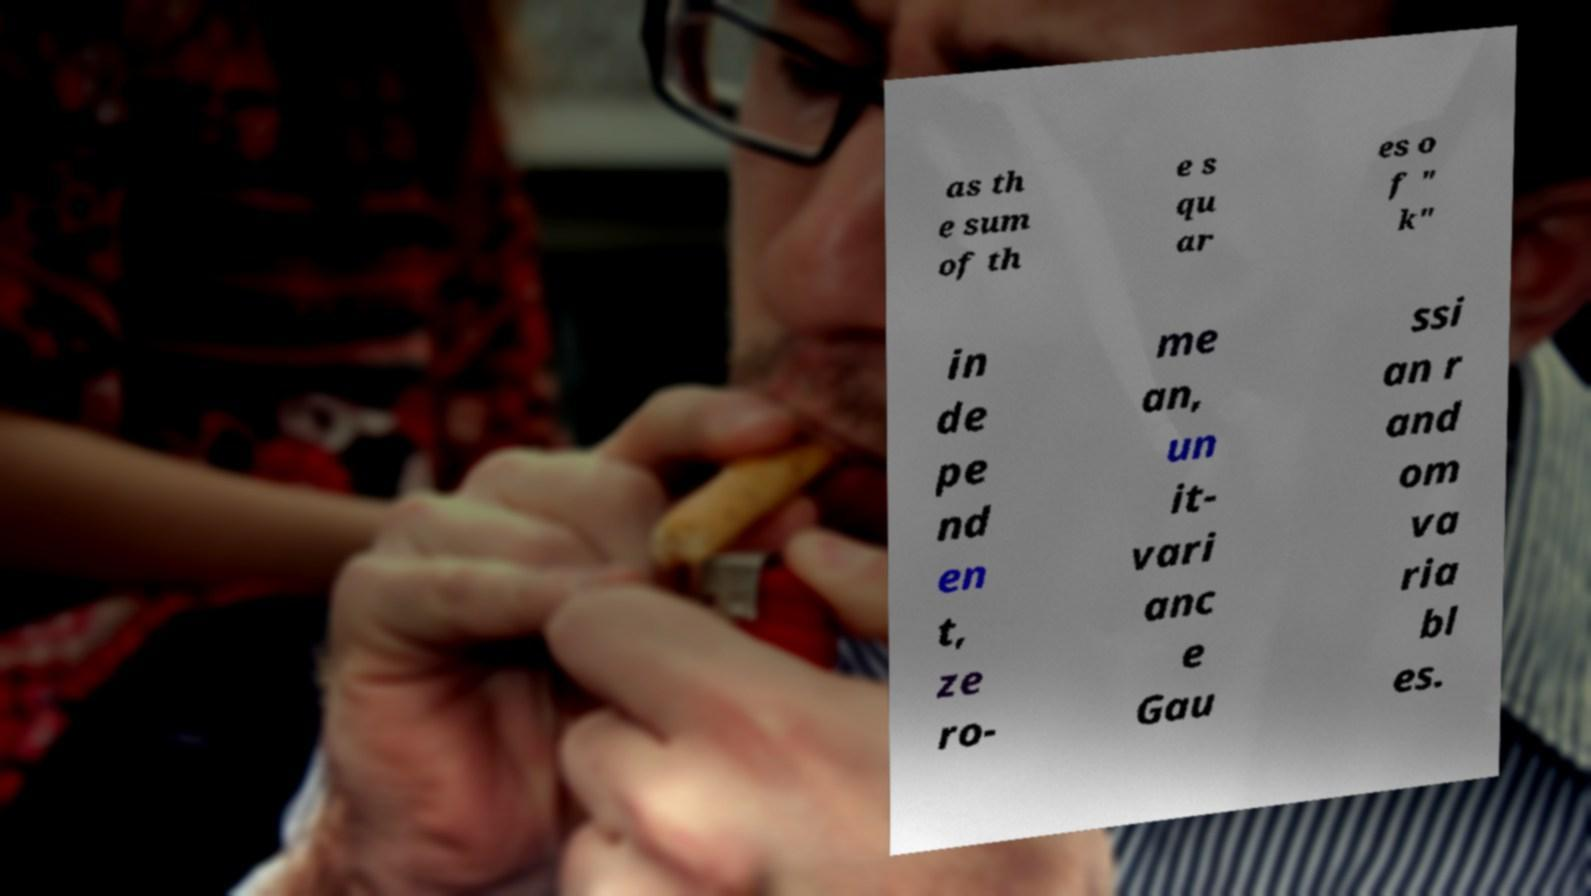What messages or text are displayed in this image? I need them in a readable, typed format. as th e sum of th e s qu ar es o f " k" in de pe nd en t, ze ro- me an, un it- vari anc e Gau ssi an r and om va ria bl es. 